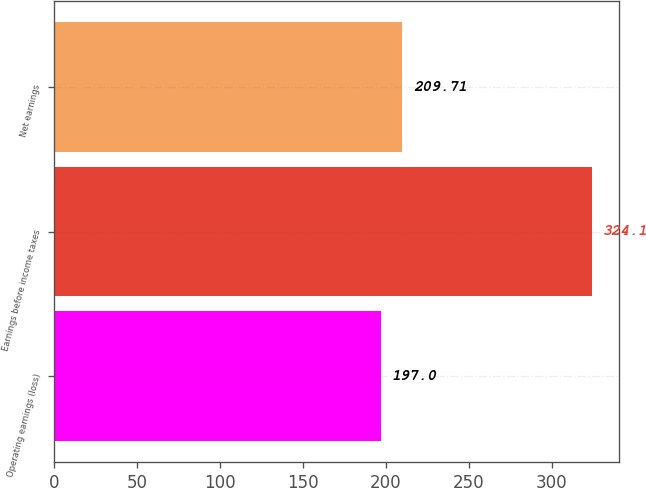Convert chart to OTSL. <chart><loc_0><loc_0><loc_500><loc_500><bar_chart><fcel>Operating earnings (loss)<fcel>Earnings before income taxes<fcel>Net earnings<nl><fcel>197<fcel>324.1<fcel>209.71<nl></chart> 